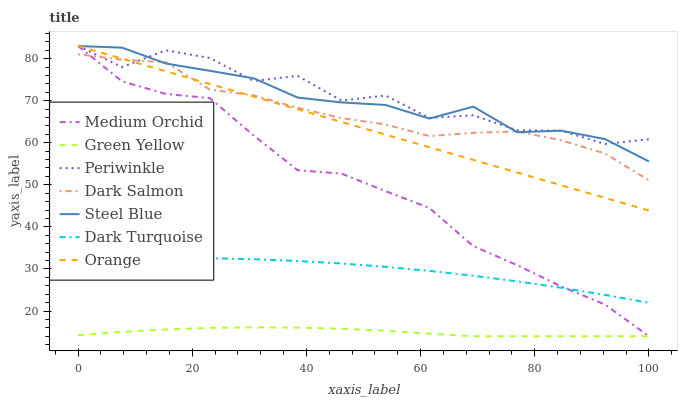Does Green Yellow have the minimum area under the curve?
Answer yes or no. Yes. Does Periwinkle have the maximum area under the curve?
Answer yes or no. Yes. Does Medium Orchid have the minimum area under the curve?
Answer yes or no. No. Does Medium Orchid have the maximum area under the curve?
Answer yes or no. No. Is Orange the smoothest?
Answer yes or no. Yes. Is Periwinkle the roughest?
Answer yes or no. Yes. Is Medium Orchid the smoothest?
Answer yes or no. No. Is Medium Orchid the roughest?
Answer yes or no. No. Does Medium Orchid have the lowest value?
Answer yes or no. Yes. Does Dark Salmon have the lowest value?
Answer yes or no. No. Does Orange have the highest value?
Answer yes or no. Yes. Does Dark Salmon have the highest value?
Answer yes or no. No. Is Green Yellow less than Steel Blue?
Answer yes or no. Yes. Is Orange greater than Green Yellow?
Answer yes or no. Yes. Does Dark Salmon intersect Orange?
Answer yes or no. Yes. Is Dark Salmon less than Orange?
Answer yes or no. No. Is Dark Salmon greater than Orange?
Answer yes or no. No. Does Green Yellow intersect Steel Blue?
Answer yes or no. No. 